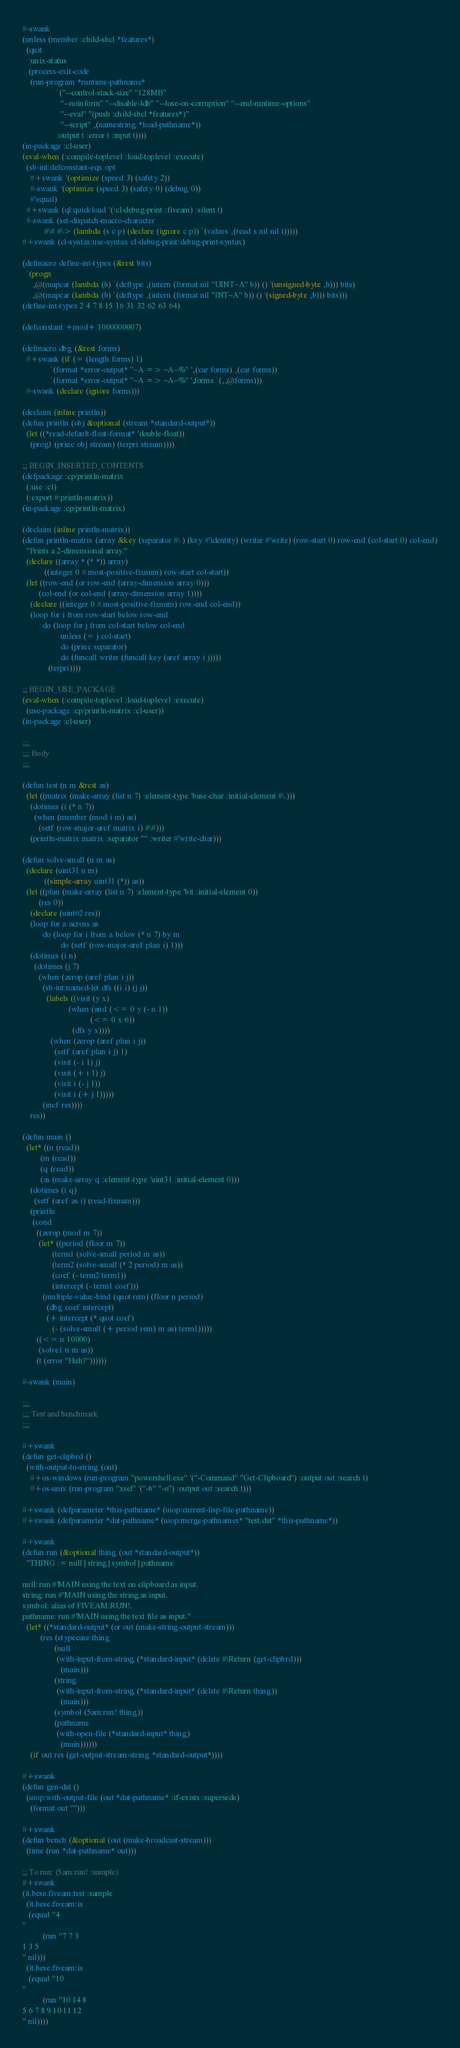Convert code to text. <code><loc_0><loc_0><loc_500><loc_500><_Lisp_>#-swank
(unless (member :child-sbcl *features*)
  (quit
   :unix-status
   (process-exit-code
    (run-program *runtime-pathname*
                 `("--control-stack-size" "128MB"
                   "--noinform" "--disable-ldb" "--lose-on-corruption" "--end-runtime-options"
                   "--eval" "(push :child-sbcl *features*)"
                   "--script" ,(namestring *load-pathname*))
                 :output t :error t :input t))))
(in-package :cl-user)
(eval-when (:compile-toplevel :load-toplevel :execute)
  (sb-int:defconstant-eqx opt
    #+swank '(optimize (speed 3) (safety 2))
    #-swank '(optimize (speed 3) (safety 0) (debug 0))
    #'equal)
  #+swank (ql:quickload '(:cl-debug-print :fiveam) :silent t)
  #-swank (set-dispatch-macro-character
           #\# #\> (lambda (s c p) (declare (ignore c p)) `(values ,(read s nil nil t)))))
#+swank (cl-syntax:use-syntax cl-debug-print:debug-print-syntax)

(defmacro define-int-types (&rest bits)
  `(progn
     ,@(mapcar (lambda (b) `(deftype ,(intern (format nil "UINT~A" b)) () '(unsigned-byte ,b))) bits)
     ,@(mapcar (lambda (b) `(deftype ,(intern (format nil "INT~A" b)) () '(signed-byte ,b))) bits)))
(define-int-types 2 4 7 8 15 16 31 32 62 63 64)

(defconstant +mod+ 1000000007)

(defmacro dbg (&rest forms)
  #+swank (if (= (length forms) 1)
              `(format *error-output* "~A => ~A~%" ',(car forms) ,(car forms))
              `(format *error-output* "~A => ~A~%" ',forms `(,,@forms)))
  #-swank (declare (ignore forms)))

(declaim (inline println))
(defun println (obj &optional (stream *standard-output*))
  (let ((*read-default-float-format* 'double-float))
    (prog1 (princ obj stream) (terpri stream))))

;; BEGIN_INSERTED_CONTENTS
(defpackage :cp/println-matrix
  (:use :cl)
  (:export #:println-matrix))
(in-package :cp/println-matrix)

(declaim (inline println-matrix))
(defun println-matrix (array &key (separator #\ ) (key #'identity) (writer #'write) (row-start 0) row-end (col-start 0) col-end)
  "Prints a 2-dimensional array."
  (declare ((array * (* *)) array)
           ((integer 0 #.most-positive-fixnum) row-start col-start))
  (let ((row-end (or row-end (array-dimension array 0)))
        (col-end (or col-end (array-dimension array 1))))
    (declare ((integer 0 #.most-positive-fixnum) row-end col-end))
    (loop for i from row-start below row-end
          do (loop for j from col-start below col-end
                   unless (= j col-start)
                   do (princ separator)
                   do (funcall writer (funcall key (aref array i j))))
             (terpri))))

;; BEGIN_USE_PACKAGE
(eval-when (:compile-toplevel :load-toplevel :execute)
  (use-package :cp/println-matrix :cl-user))
(in-package :cl-user)

;;;
;;; Body
;;;

(defun test (n m &rest as)
  (let ((matrix (make-array (list n 7) :element-type 'base-char :initial-element #\.)))
    (dotimes (i (* n 7))
      (when (member (mod i m) as)
        (setf (row-major-aref matrix i) #\#)))
    (println-matrix matrix :separator "" :writer #'write-char)))

(defun solve-small (n m as)
  (declare (uint31 n m)
           ((simple-array uint31 (*)) as))
  (let ((plan (make-array (list n 7) :element-type 'bit :initial-element 0))
        (res 0))
    (declare (uint62 res))
    (loop for a across as
          do (loop for i from a below (* n 7) by m
                   do (setf (row-major-aref plan i) 1)))
    (dotimes (i n)
      (dotimes (j 7)
        (when (zerop (aref plan i j))
          (sb-int:named-let dfs ((i i) (j j))
            (labels ((visit (y x)
                       (when (and (<= 0 y (- n 1))
                                  (<= 0 x 6))
                         (dfs y x))))
              (when (zerop (aref plan i j))
                (setf (aref plan i j) 1)
                (visit (- i 1) j)
                (visit (+ i 1) j)
                (visit i (- j 1))
                (visit i (+ j 1)))))
          (incf res))))
    res))

(defun main ()
  (let* ((n (read))
         (m (read))
         (q (read))
         (as (make-array q :element-type 'uint31 :initial-element 0)))
    (dotimes (i q)
      (setf (aref as i) (read-fixnum)))
    (println
     (cond
       ((zerop (mod m 7))
        (let* ((period (floor m 7))
               (term1 (solve-small period m as))
               (term2 (solve-small (* 2 period) m as))
               (coef (- term2 term1))
               (intercept (- term1 coef)))
          (multiple-value-bind (quot rem) (floor n period)
            (dbg coef intercept)
            (+ intercept (* quot coef)
               (- (solve-small (+ period rem) m as) term1)))))
       ((<= n 10000)
        (solve1 n m as))
       (t (error "Huh?"))))))

#-swank (main)

;;;
;;; Test and benchmark
;;;

#+swank
(defun get-clipbrd ()
  (with-output-to-string (out)
    #+os-windows (run-program "powershell.exe" '("-Command" "Get-Clipboard") :output out :search t)
    #+os-unix (run-program "xsel" '("-b" "-o") :output out :search t)))

#+swank (defparameter *this-pathname* (uiop:current-lisp-file-pathname))
#+swank (defparameter *dat-pathname* (uiop:merge-pathnames* "test.dat" *this-pathname*))

#+swank
(defun run (&optional thing (out *standard-output*))
  "THING := null | string | symbol | pathname

null: run #'MAIN using the text on clipboard as input.
string: run #'MAIN using the string as input.
symbol: alias of FIVEAM:RUN!.
pathname: run #'MAIN using the text file as input."
  (let* ((*standard-output* (or out (make-string-output-stream)))
         (res (etypecase thing
                (null
                 (with-input-from-string (*standard-input* (delete #\Return (get-clipbrd)))
                   (main)))
                (string
                 (with-input-from-string (*standard-input* (delete #\Return thing))
                   (main)))
                (symbol (5am:run! thing))
                (pathname
                 (with-open-file (*standard-input* thing)
                   (main))))))
    (if out res (get-output-stream-string *standard-output*))))

#+swank
(defun gen-dat ()
  (uiop:with-output-file (out *dat-pathname* :if-exists :supersede)
    (format out "")))

#+swank
(defun bench (&optional (out (make-broadcast-stream)))
  (time (run *dat-pathname* out)))

;; To run: (5am:run! :sample)
#+swank
(it.bese.fiveam:test :sample
  (it.bese.fiveam:is
   (equal "4
"
          (run "7 7 3
1 3 5
" nil)))
  (it.bese.fiveam:is
   (equal "10
"
          (run "10 14 8
5 6 7 8 9 10 11 12
" nil))))
</code> 